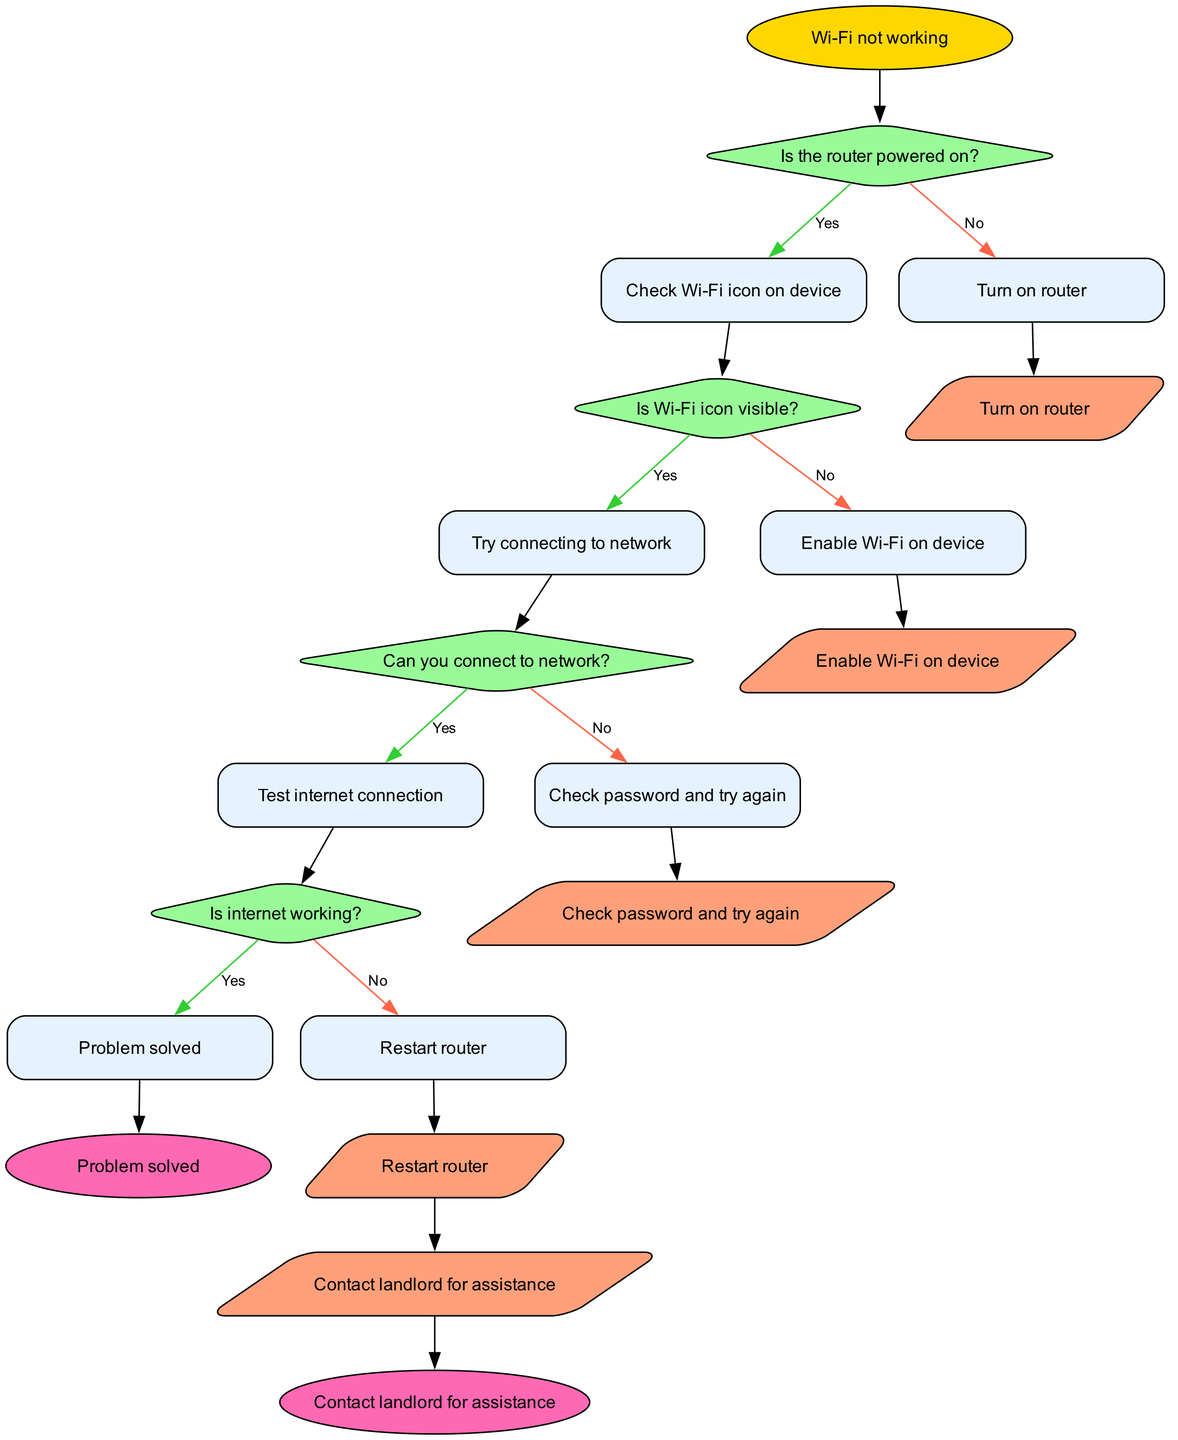What is the first step in the flowchart? The first step in the flowchart is the "Wi-Fi not working" start node, which initiates the troubleshooting process.
Answer: Wi-Fi not working How many decisions are made in the flowchart? There are four decisions made in the flowchart, each represented by a diamond-shaped node with a question.
Answer: 4 What is the action taken if the router is not powered on? If the router is not powered on, the action is to "Turn on router," which is indicated as the next step in the flowchart.
Answer: Turn on router What should you do if you can’t connect to the network? If you can't connect to the network, the flowchart advises to "Check password and try again" as the next step.
Answer: Check password and try again What happens after the decision "Is internet working?" if the answer is yes? If the answer to "Is internet working?" is yes, the flowchart indicates that the problem is solved, leading to the end node.
Answer: Problem solved What is the last action before contacting the landlord for assistance? The last action before contacting the landlord for assistance is "Restart router," which is linked from one of the no responses in the flowchart.
Answer: Restart router How many end nodes are there in the flowchart? There are two end nodes in the flowchart, which signify the outcomes of the troubleshooting process.
Answer: 2 What color is used for question nodes in the flowchart? The question nodes, which represent decision points, are colored light green (#98FB98) as per the styling in the diagram.
Answer: Light green What is the label for the yes edge from the last decision? The label for the yes edge from the last decision "Is internet working?" is "Yes," leading to the end node indicating the problem is solved.
Answer: Yes 